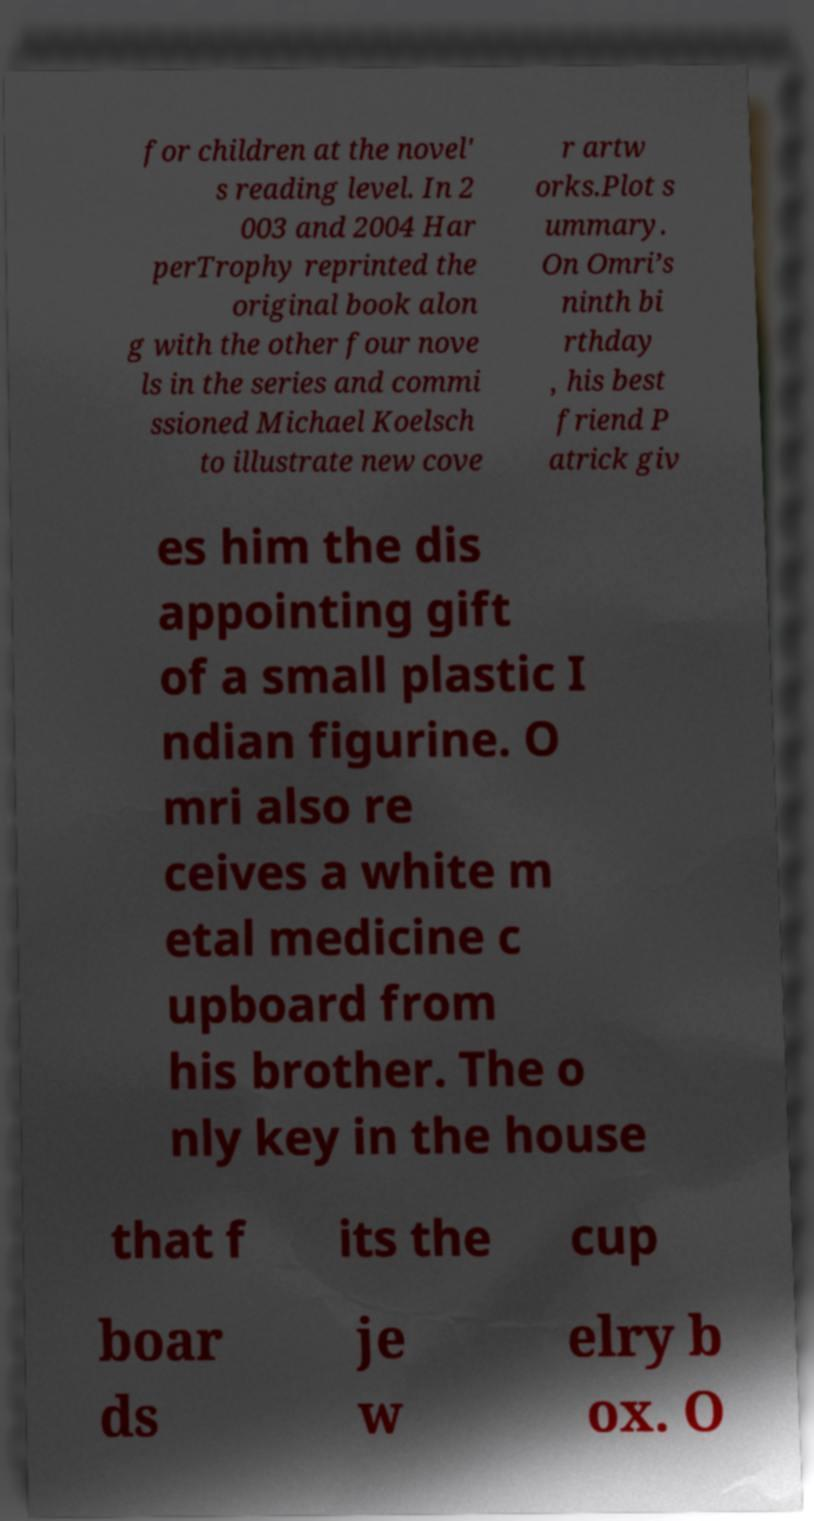Could you extract and type out the text from this image? for children at the novel' s reading level. In 2 003 and 2004 Har perTrophy reprinted the original book alon g with the other four nove ls in the series and commi ssioned Michael Koelsch to illustrate new cove r artw orks.Plot s ummary. On Omri’s ninth bi rthday , his best friend P atrick giv es him the dis appointing gift of a small plastic I ndian figurine. O mri also re ceives a white m etal medicine c upboard from his brother. The o nly key in the house that f its the cup boar ds je w elry b ox. O 